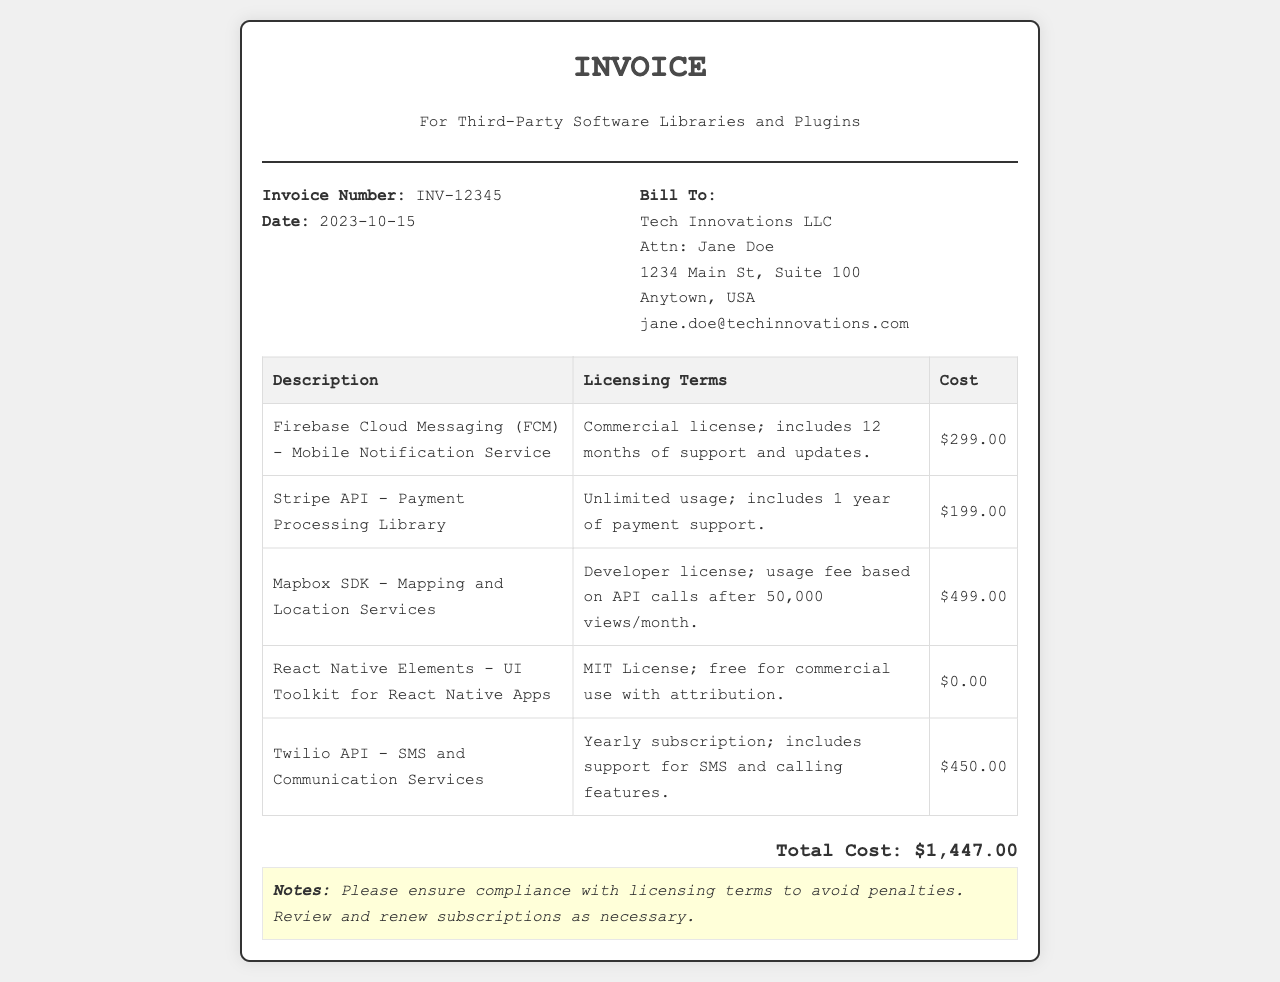What is the invoice number? The invoice number is specified in the document under the "Invoice Number" section.
Answer: INV-12345 What is the date of the invoice? The date is listed near the invoice number, indicating when the invoice was issued.
Answer: 2023-10-15 Who is the bill to? The billing information provides the name and details of the recipient of the invoice.
Answer: Tech Innovations LLC What is the total cost of the invoice? The total cost is calculated as the sum of all individual costs listed in the table.
Answer: $1,447.00 What license type does Firebase Cloud Messaging fall under? The licensing terms for Firebase Cloud Messaging specify the type of license associated with its use.
Answer: Commercial license How many months of support does the Firebase Cloud Messaging include? The support duration is mentioned in the licensing terms of Firebase Cloud Messaging.
Answer: 12 months What additional costs apply to the Mapbox SDK after how many views? The licensing terms detail the usage conditions and fees related to the Mapbox SDK.
Answer: 50,000 views/month What payment support duration is included with the Stripe API? The licensing terms indicate the length of payment support associated with the use of the Stripe API.
Answer: 1 year What should be ensured to avoid penalties? The notes section advises on compliance related to the invoice content.
Answer: Compliance with licensing terms 